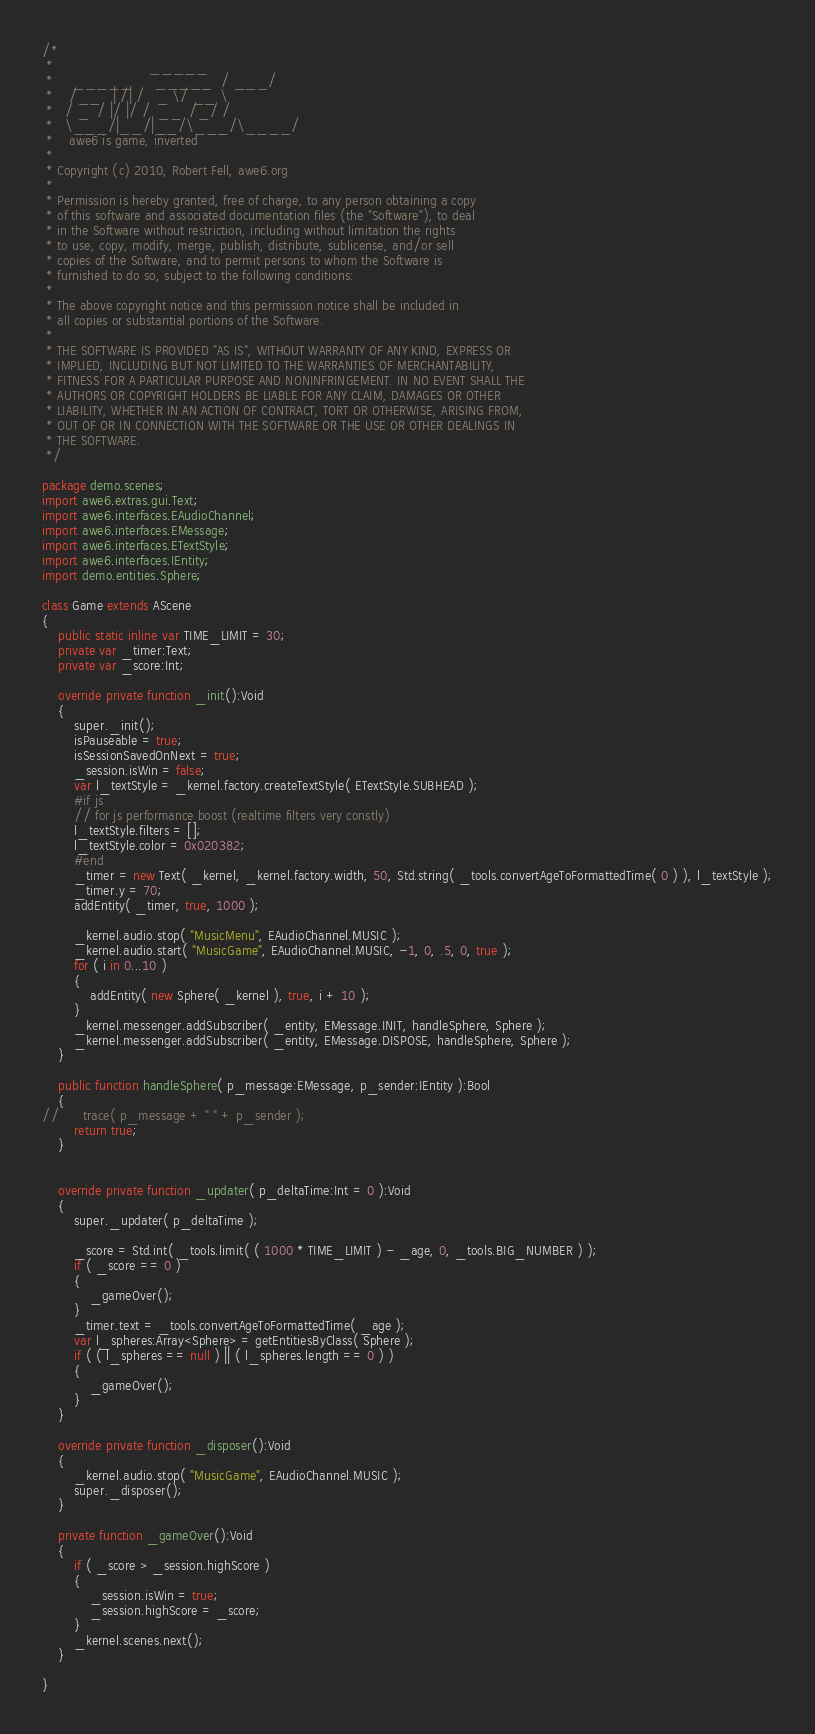Convert code to text. <code><loc_0><loc_0><loc_500><loc_500><_Haxe_>/*
 *                        _____
 *     _____      _____  / ___/
 *    /__   | /| /   _ \/ __ \
 *   / _  / |/ |/ /  __  /_/ /
 *   \___/|__/|__/\___/\____/
 *    awe6 is game, inverted
 *
 * Copyright (c) 2010, Robert Fell, awe6.org
 *
 * Permission is hereby granted, free of charge, to any person obtaining a copy
 * of this software and associated documentation files (the "Software"), to deal
 * in the Software without restriction, including without limitation the rights
 * to use, copy, modify, merge, publish, distribute, sublicense, and/or sell
 * copies of the Software, and to permit persons to whom the Software is
 * furnished to do so, subject to the following conditions:
 *
 * The above copyright notice and this permission notice shall be included in
 * all copies or substantial portions of the Software.
 *
 * THE SOFTWARE IS PROVIDED "AS IS", WITHOUT WARRANTY OF ANY KIND, EXPRESS OR
 * IMPLIED, INCLUDING BUT NOT LIMITED TO THE WARRANTIES OF MERCHANTABILITY,
 * FITNESS FOR A PARTICULAR PURPOSE AND NONINFRINGEMENT. IN NO EVENT SHALL THE
 * AUTHORS OR COPYRIGHT HOLDERS BE LIABLE FOR ANY CLAIM, DAMAGES OR OTHER
 * LIABILITY, WHETHER IN AN ACTION OF CONTRACT, TORT OR OTHERWISE, ARISING FROM,
 * OUT OF OR IN CONNECTION WITH THE SOFTWARE OR THE USE OR OTHER DEALINGS IN
 * THE SOFTWARE.
 */

package demo.scenes;
import awe6.extras.gui.Text;
import awe6.interfaces.EAudioChannel;
import awe6.interfaces.EMessage;
import awe6.interfaces.ETextStyle;
import awe6.interfaces.IEntity;
import demo.entities.Sphere;

class Game extends AScene
{
	public static inline var TIME_LIMIT = 30;
	private var _timer:Text;
	private var _score:Int;

	override private function _init():Void
	{
		super._init();
		isPauseable = true;
		isSessionSavedOnNext = true;
		_session.isWin = false;
		var l_textStyle = _kernel.factory.createTextStyle( ETextStyle.SUBHEAD );
		#if js
		// for js performance boost (realtime filters very constly)
		l_textStyle.filters = [];
		l_textStyle.color = 0x020382;
		#end
		_timer = new Text( _kernel, _kernel.factory.width, 50, Std.string( _tools.convertAgeToFormattedTime( 0 ) ), l_textStyle );
		_timer.y = 70;
		addEntity( _timer, true, 1000 );

		_kernel.audio.stop( "MusicMenu", EAudioChannel.MUSIC );
		_kernel.audio.start( "MusicGame", EAudioChannel.MUSIC, -1, 0, .5, 0, true );
		for ( i in 0...10 )
		{
			addEntity( new Sphere( _kernel ), true, i + 10 );
		}
		_kernel.messenger.addSubscriber( _entity, EMessage.INIT, handleSphere, Sphere );
		_kernel.messenger.addSubscriber( _entity, EMessage.DISPOSE, handleSphere, Sphere );
	}
	
	public function handleSphere( p_message:EMessage, p_sender:IEntity ):Bool
	{
//		trace( p_message + " " + p_sender );
		return true;
	}
	

	override private function _updater( p_deltaTime:Int = 0 ):Void
	{
		super._updater( p_deltaTime );

		_score = Std.int( _tools.limit( ( 1000 * TIME_LIMIT ) - _age, 0, _tools.BIG_NUMBER ) );
		if ( _score == 0 )
		{
			_gameOver();
		}
		_timer.text = _tools.convertAgeToFormattedTime( _age );
		var l_spheres:Array<Sphere> = getEntitiesByClass( Sphere );
		if ( ( l_spheres == null ) || ( l_spheres.length == 0 ) )
		{
			_gameOver();
		}
	}

	override private function _disposer():Void
	{
		_kernel.audio.stop( "MusicGame", EAudioChannel.MUSIC );
		super._disposer();
	}

	private function _gameOver():Void
	{
		if ( _score > _session.highScore )
		{
			_session.isWin = true;
			_session.highScore = _score;
		}
		_kernel.scenes.next();
	}

}
</code> 